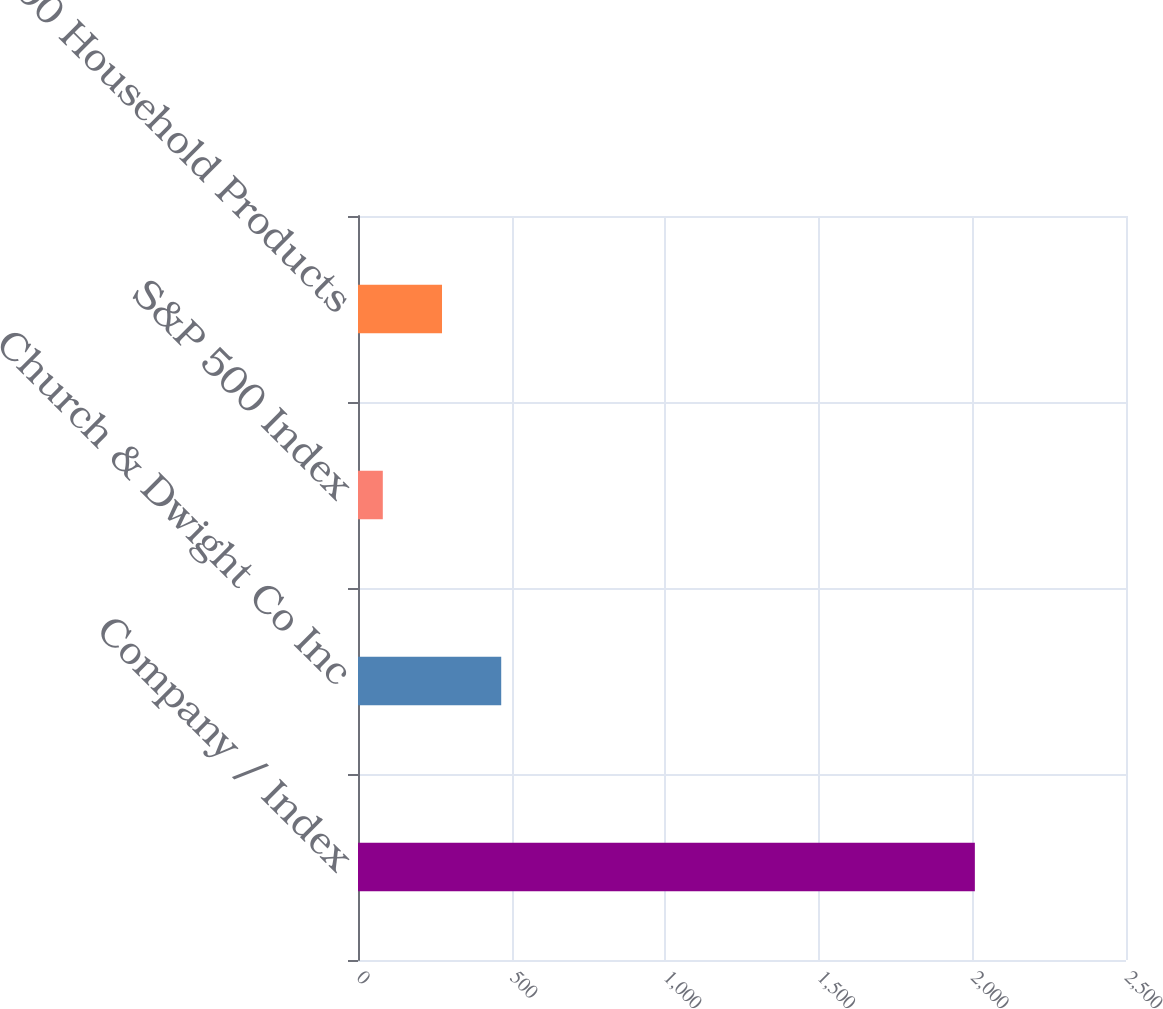Convert chart to OTSL. <chart><loc_0><loc_0><loc_500><loc_500><bar_chart><fcel>Company / Index<fcel>Church & Dwight Co Inc<fcel>S&P 500 Index<fcel>S&P 500 Household Products<nl><fcel>2008<fcel>466.2<fcel>80.74<fcel>273.47<nl></chart> 